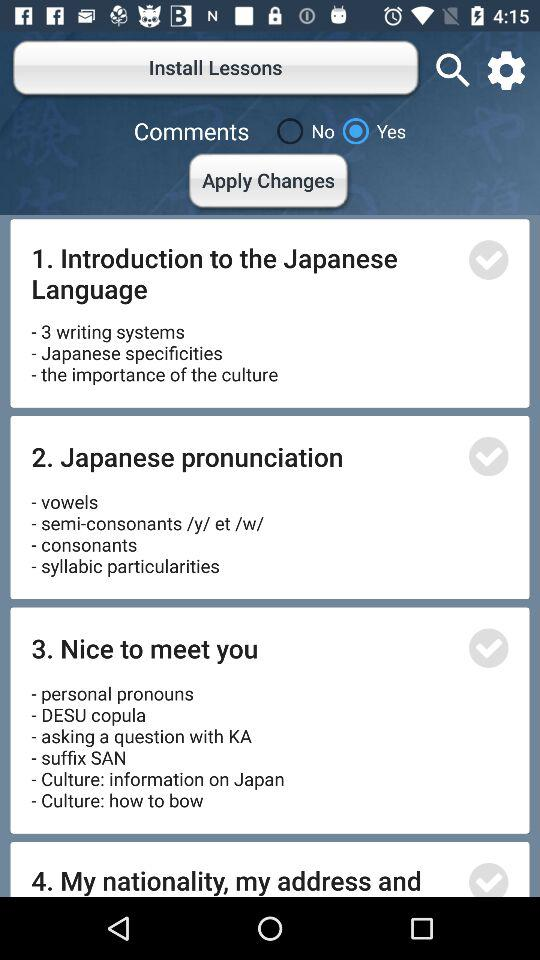How many lessons are there in total?
Answer the question using a single word or phrase. 4 